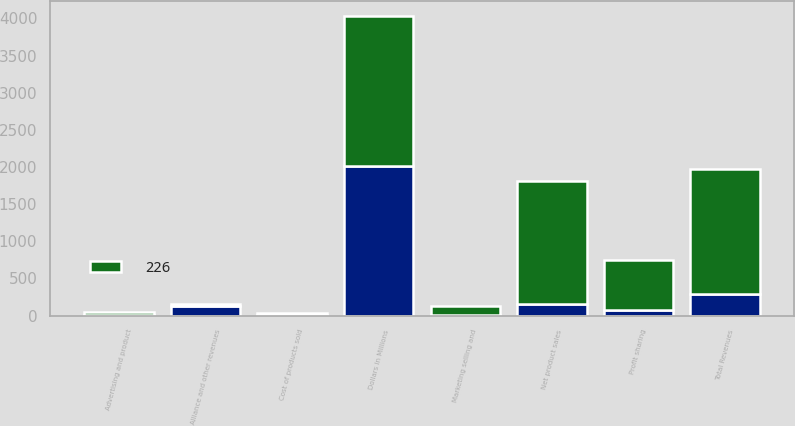Convert chart. <chart><loc_0><loc_0><loc_500><loc_500><stacked_bar_chart><ecel><fcel>Dollars in Millions<fcel>Net product sales<fcel>Alliance and other revenues<fcel>Total Revenues<fcel>Profit sharing<fcel>Cost of products sold<fcel>Marketing selling and<fcel>Advertising and product<nl><fcel>nan<fcel>2014<fcel>160<fcel>135<fcel>295<fcel>79<fcel>9<fcel>6<fcel>2<nl><fcel>226<fcel>2013<fcel>1658<fcel>16<fcel>1674<fcel>673<fcel>25<fcel>127<fcel>45<nl></chart> 